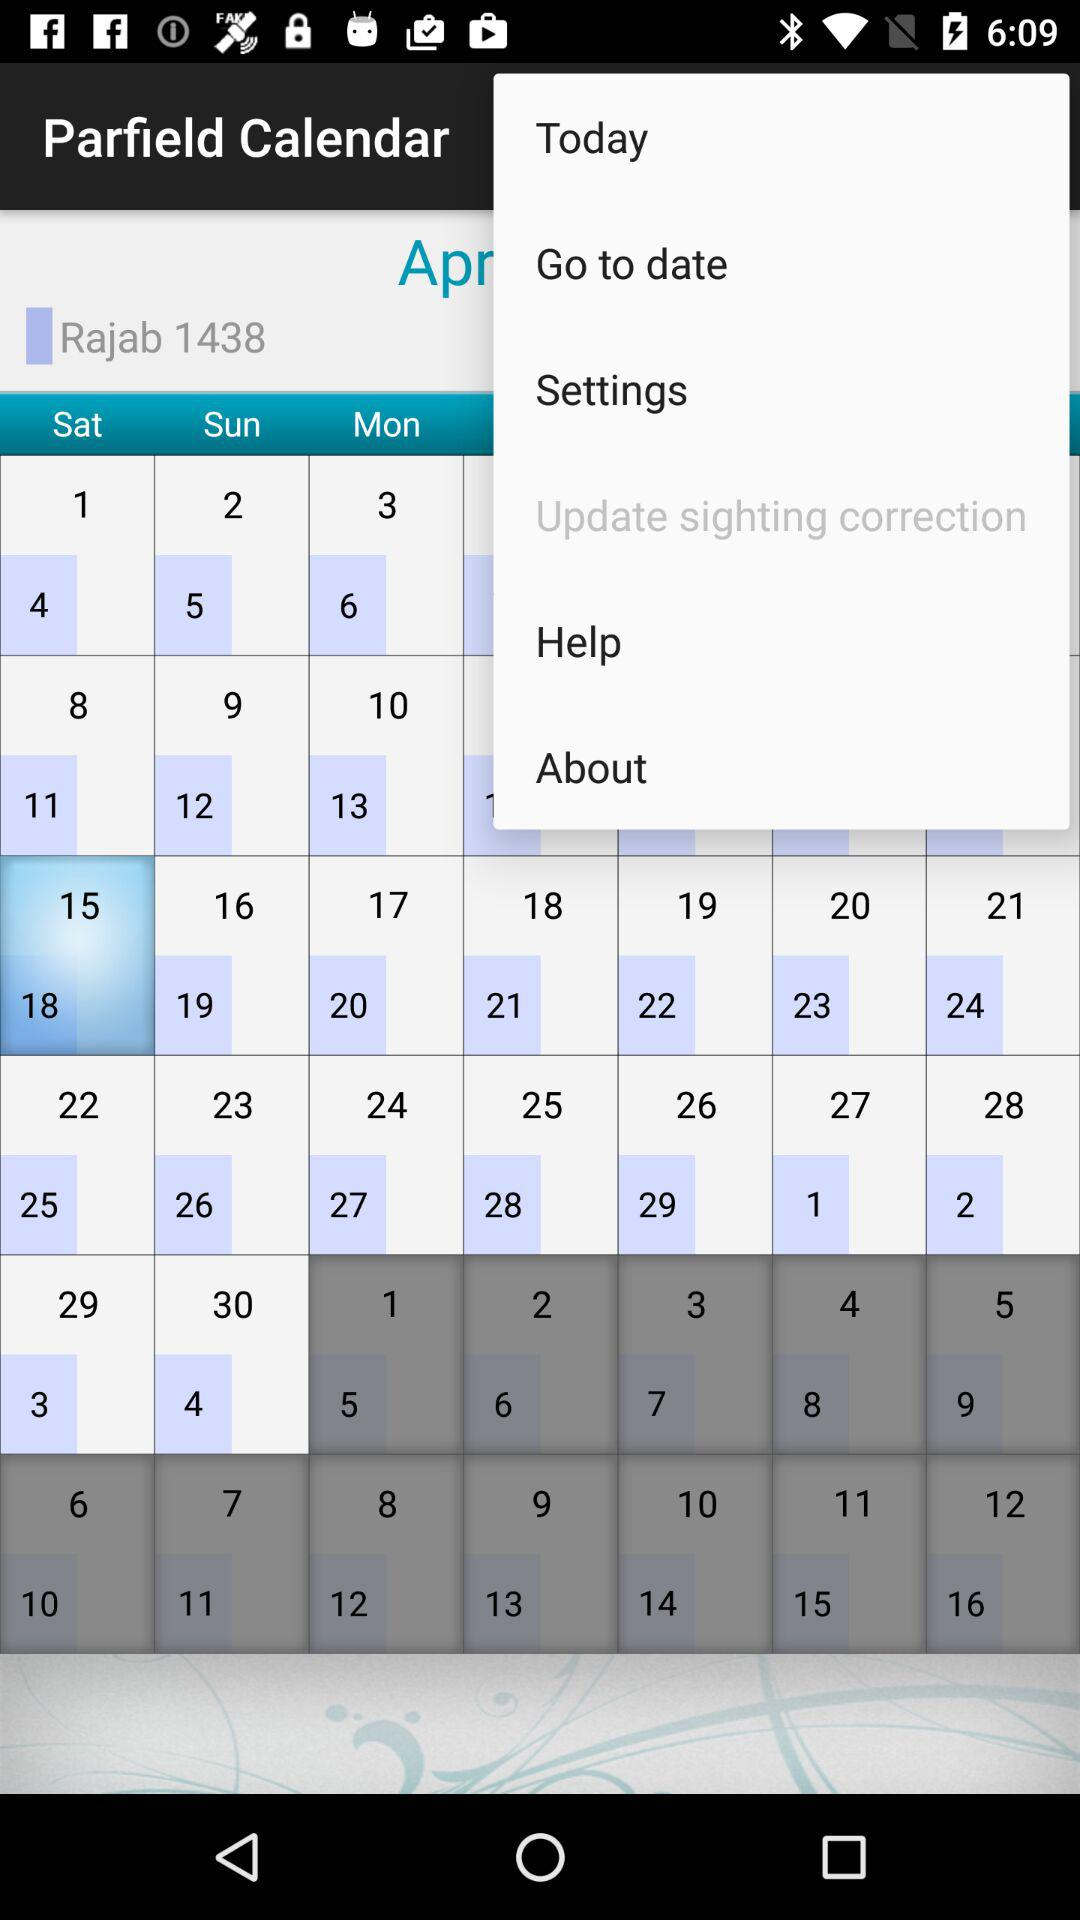What are the selected dates? The selected dates are: April 15 and April 18. 